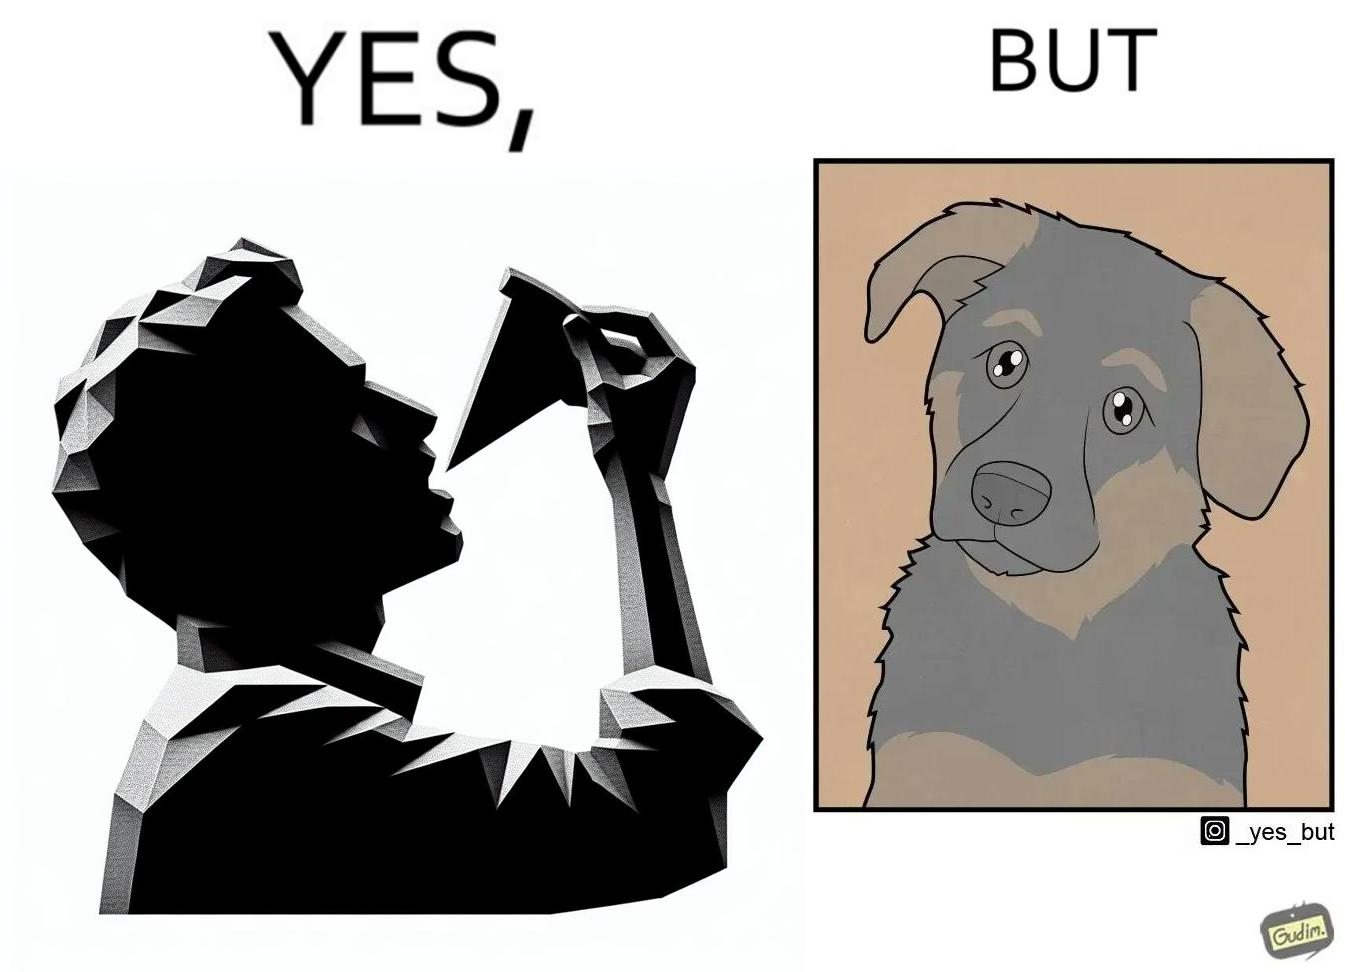Why is this image considered satirical? The images are funny since they show how pet owners cannot enjoy any tasty food like pizza without sharing with their pets. The look from the pets makes the owner too guilty if he does not share his food 